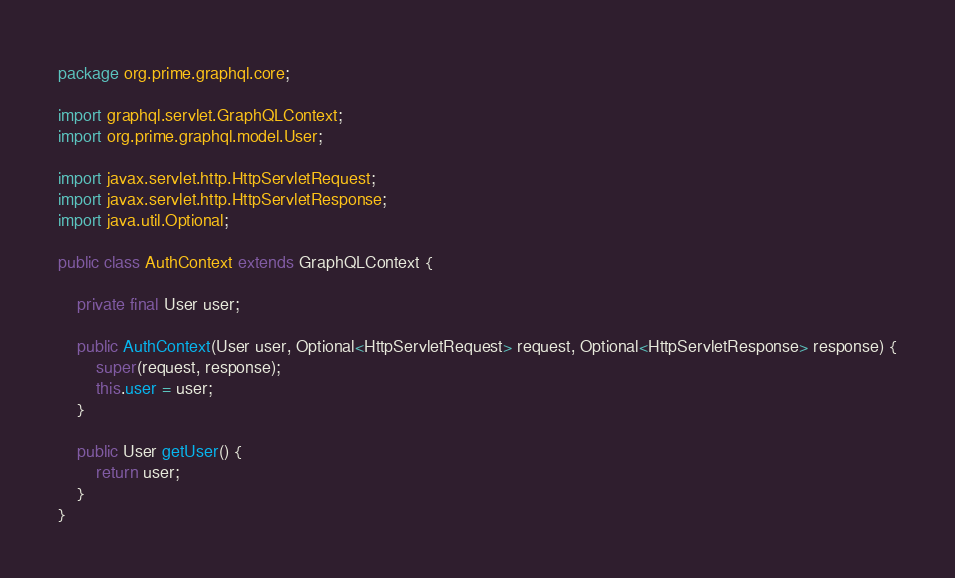<code> <loc_0><loc_0><loc_500><loc_500><_Java_>package org.prime.graphql.core;

import graphql.servlet.GraphQLContext;
import org.prime.graphql.model.User;

import javax.servlet.http.HttpServletRequest;
import javax.servlet.http.HttpServletResponse;
import java.util.Optional;

public class AuthContext extends GraphQLContext {

    private final User user;

    public AuthContext(User user, Optional<HttpServletRequest> request, Optional<HttpServletResponse> response) {
        super(request, response);
        this.user = user;
    }

    public User getUser() {
        return user;
    }
}
</code> 